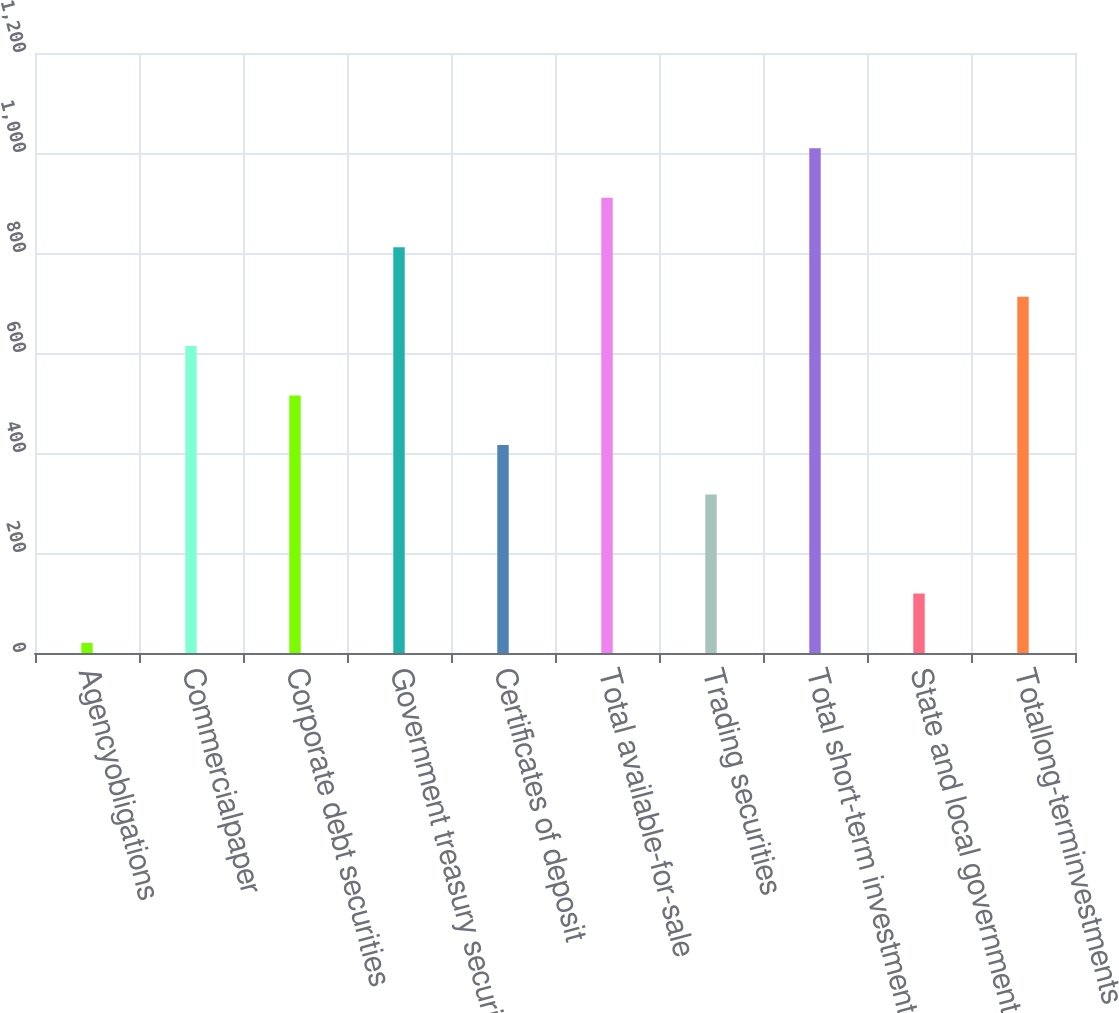Convert chart to OTSL. <chart><loc_0><loc_0><loc_500><loc_500><bar_chart><fcel>Agencyobligations<fcel>Commercialpaper<fcel>Corporate debt securities<fcel>Government treasury securities<fcel>Certificates of deposit<fcel>Total available-for-sale<fcel>Trading securities<fcel>Total short-term investments<fcel>State and local government<fcel>Totallong-terminvestments<nl><fcel>20<fcel>613.76<fcel>514.8<fcel>811.68<fcel>415.84<fcel>910.64<fcel>316.88<fcel>1009.6<fcel>118.96<fcel>712.72<nl></chart> 